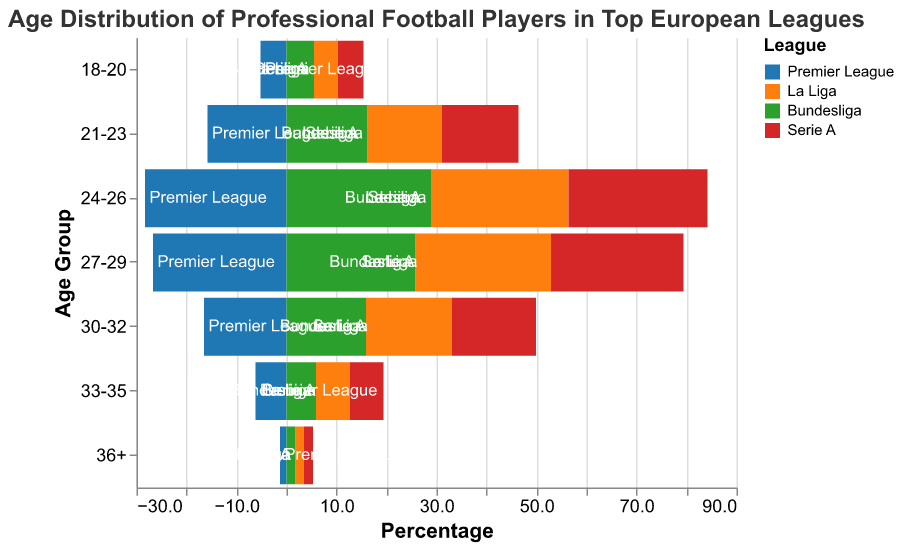What percentage of players in the Premier League are aged 24-26? Looking at the bar for "24-26" in the Premier League, the percentage value is labeled as 28.3.
Answer: 28.3 Which age group has the highest percentage of players in La Liga? Among the age group bars in La Liga, "24-26" has the tallest bar, indicating a percentage of 27.5, which is the highest.
Answer: 24-26 Between Bundesliga and Serie A, which league has a higher percentage of players aged 27-29? Comparing the bars for the age group "27-29," Bundesliga has 25.8% and Serie A has 26.5%. Serie A has the higher percentage.
Answer: Serie A What's the difference in percentage of players aged 33-35 between La Liga and the Premier League? The La Liga bar for "33-35" shows a value of 6.8%, and the Premier League shows 6.2%. The difference is 6.8% - 6.2% = 0.6%.
Answer: 0.6 How many leagues have a percentage greater than 1.5% for players aged 36+? Checking each league for the percentage of players aged 36+: Premier League (1.3%), La Liga (1.7%), Bundesliga (1.8%), and Serie A (1.8%). Three leagues (La Liga, Bundesliga, Serie A) have percentages greater than 1.5%.
Answer: 3 Which age group in the Bundesliga has the lowest percentage of players? The shortest bar in the Bundesliga is for the "36+" age group, showing a percentage of 1.8%. This is the lowest among all age groups in the Bundesliga.
Answer: 36+ Order the leagues by the percentage of players aged 21-23 from highest to lowest. Looking at the bars for "21-23" across leagues, the percentages are: Bundesliga (16.2%), Premier League (15.8%), Serie A (15.3%), La Liga (14.9%). Ordered from highest to lowest: Bundesliga, Premier League, Serie A, La Liga.
Answer: Bundesliga, Premier League, Serie A, La Liga What percentage of players aged 18-20 are there in Serie A, and how does it compare to Bundesliga? Serie A has a percentage of 5.1% for players aged 18-20, while Bundesliga has 5.5%. Comparing these shows that Serie A has 0.4% fewer players in this age group than Bundesliga.
Answer: 5.1%, 0.4% fewer What is the combined percentage of players aged 30-32 in the Premier League and Bundesliga? The percentage of players aged 30-32 is 16.5% in the Premier League and 15.9% in the Bundesliga. The combined percentage is 16.5% + 15.9% = 32.4%.
Answer: 32.4 